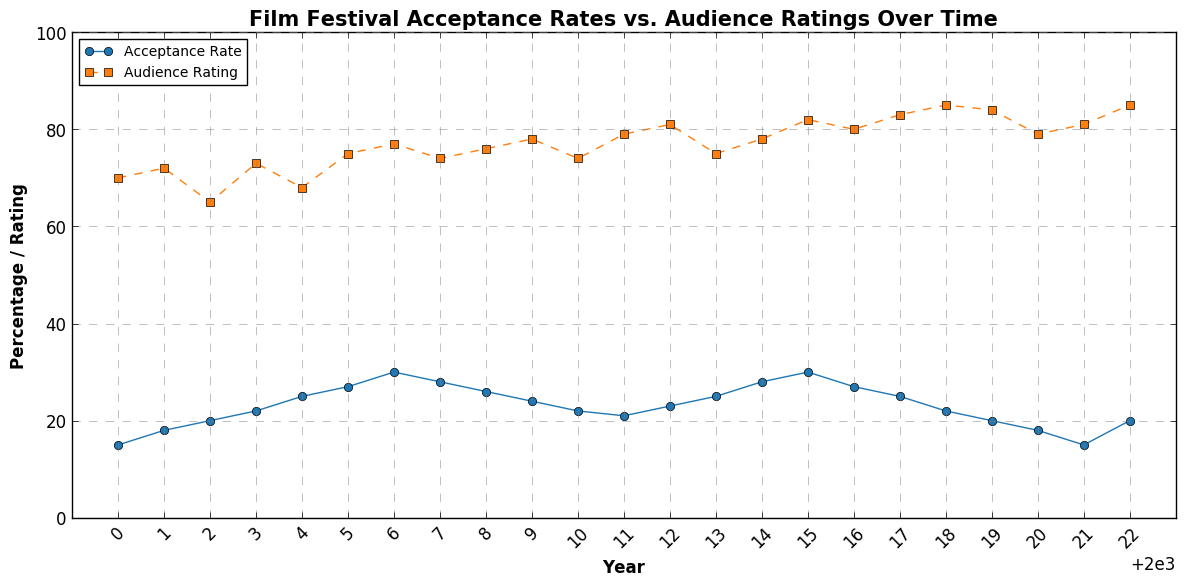Which year had the highest audience rating? By looking at the Audience Rating line (orange dashed line), the highest point appears in 2018 and 2022. Both points corresponding to these years show the highest rating.
Answer: 2018, 2022 In which year did the acceptance rate peak? The blue line representing the Acceptance Rate peaked in 2015 with a value of 30.
Answer: 2015 What is the difference in audience rating between 2000 and 2022? The Audience Rating in 2000 was 70 and in 2022 it was 85. The difference is 85 - 70 = 15.
Answer: 15 How did the acceptance rate change from 2000 to 2005? The Acceptance Rate in 2000 was 15, and by 2005 it increased to 27. The change is 27 - 15 = 12.
Answer: Increased by 12 Which year saw the largest drop in acceptance rate compared to the previous year? By observing the blue line, the largest drop in the Acceptance Rate appears between 2019 (20) and 2020 (18), a drop of 2.
Answer: 2019 to 2020 Did acceptance rates and audience ratings ever increase or decrease simultaneously? Yes, between 2000 and 2001, both acceptance rates and audience ratings increased, and similarly between 2020 and 2022.
Answer: Yes What's the average audience rating from 2018 to 2022? The Audience Ratings from 2018 to 2022 are 85, 84, 79, 81, 85. Sum these values: 85 + 84 + 79 + 81 + 85 = 414. Divide by 5: 414/5 = 82.8.
Answer: 82.8 By how much did the audience rating change from 2019 to 2020? The Audience Rating in 2019 was 84 and in 2020 it was 79. The change is 79 - 84 = -5.
Answer: Decreased by 5 Compare the acceptance rates between 2014 and 2015 and describe the change. The Acceptance Rate in 2014 was 28, and in 2015 it was 30. The change is 30 - 28 = 2.
Answer: Increased by 2 Which line (Acceptance Rate or Audience Rating) shows more fluctuation over the years? By observing the two lines, the Acceptance Rate line (blue) shows more peaks and troughs compared to the Audience Rating line (orange). Thus, the Acceptance Rate shows more fluctuation.
Answer: Acceptance Rate 